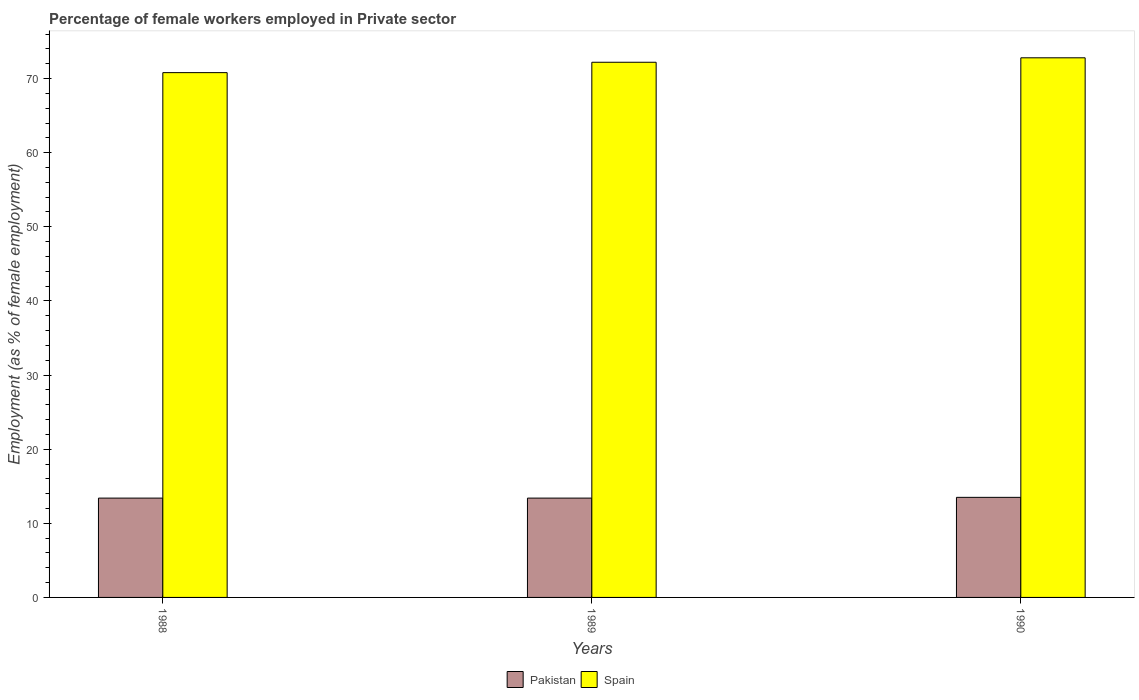How many different coloured bars are there?
Keep it short and to the point. 2. How many groups of bars are there?
Offer a very short reply. 3. How many bars are there on the 2nd tick from the left?
Ensure brevity in your answer.  2. How many bars are there on the 2nd tick from the right?
Ensure brevity in your answer.  2. In how many cases, is the number of bars for a given year not equal to the number of legend labels?
Your response must be concise. 0. What is the percentage of females employed in Private sector in Pakistan in 1989?
Ensure brevity in your answer.  13.4. Across all years, what is the maximum percentage of females employed in Private sector in Spain?
Offer a very short reply. 72.8. Across all years, what is the minimum percentage of females employed in Private sector in Spain?
Make the answer very short. 70.8. In which year was the percentage of females employed in Private sector in Pakistan maximum?
Provide a succinct answer. 1990. What is the total percentage of females employed in Private sector in Pakistan in the graph?
Your response must be concise. 40.3. What is the difference between the percentage of females employed in Private sector in Pakistan in 1989 and that in 1990?
Offer a very short reply. -0.1. What is the difference between the percentage of females employed in Private sector in Spain in 1989 and the percentage of females employed in Private sector in Pakistan in 1990?
Give a very brief answer. 58.7. What is the average percentage of females employed in Private sector in Pakistan per year?
Offer a very short reply. 13.43. In the year 1988, what is the difference between the percentage of females employed in Private sector in Spain and percentage of females employed in Private sector in Pakistan?
Provide a succinct answer. 57.4. In how many years, is the percentage of females employed in Private sector in Pakistan greater than 60 %?
Provide a succinct answer. 0. Is the difference between the percentage of females employed in Private sector in Spain in 1989 and 1990 greater than the difference between the percentage of females employed in Private sector in Pakistan in 1989 and 1990?
Provide a succinct answer. No. What is the difference between the highest and the second highest percentage of females employed in Private sector in Spain?
Your response must be concise. 0.6. What is the difference between the highest and the lowest percentage of females employed in Private sector in Pakistan?
Your answer should be very brief. 0.1. What does the 1st bar from the right in 1988 represents?
Offer a very short reply. Spain. How many bars are there?
Your answer should be compact. 6. Are all the bars in the graph horizontal?
Your response must be concise. No. How many years are there in the graph?
Your answer should be very brief. 3. Does the graph contain grids?
Make the answer very short. No. How are the legend labels stacked?
Your response must be concise. Horizontal. What is the title of the graph?
Provide a succinct answer. Percentage of female workers employed in Private sector. Does "Antigua and Barbuda" appear as one of the legend labels in the graph?
Offer a very short reply. No. What is the label or title of the Y-axis?
Provide a succinct answer. Employment (as % of female employment). What is the Employment (as % of female employment) of Pakistan in 1988?
Your response must be concise. 13.4. What is the Employment (as % of female employment) in Spain in 1988?
Your response must be concise. 70.8. What is the Employment (as % of female employment) of Pakistan in 1989?
Offer a very short reply. 13.4. What is the Employment (as % of female employment) in Spain in 1989?
Provide a short and direct response. 72.2. What is the Employment (as % of female employment) of Pakistan in 1990?
Ensure brevity in your answer.  13.5. What is the Employment (as % of female employment) in Spain in 1990?
Provide a succinct answer. 72.8. Across all years, what is the maximum Employment (as % of female employment) of Spain?
Make the answer very short. 72.8. Across all years, what is the minimum Employment (as % of female employment) of Pakistan?
Provide a short and direct response. 13.4. Across all years, what is the minimum Employment (as % of female employment) of Spain?
Offer a terse response. 70.8. What is the total Employment (as % of female employment) of Pakistan in the graph?
Offer a very short reply. 40.3. What is the total Employment (as % of female employment) of Spain in the graph?
Give a very brief answer. 215.8. What is the difference between the Employment (as % of female employment) in Pakistan in 1988 and the Employment (as % of female employment) in Spain in 1989?
Your response must be concise. -58.8. What is the difference between the Employment (as % of female employment) of Pakistan in 1988 and the Employment (as % of female employment) of Spain in 1990?
Keep it short and to the point. -59.4. What is the difference between the Employment (as % of female employment) in Pakistan in 1989 and the Employment (as % of female employment) in Spain in 1990?
Provide a succinct answer. -59.4. What is the average Employment (as % of female employment) in Pakistan per year?
Keep it short and to the point. 13.43. What is the average Employment (as % of female employment) in Spain per year?
Your answer should be compact. 71.93. In the year 1988, what is the difference between the Employment (as % of female employment) of Pakistan and Employment (as % of female employment) of Spain?
Give a very brief answer. -57.4. In the year 1989, what is the difference between the Employment (as % of female employment) in Pakistan and Employment (as % of female employment) in Spain?
Provide a short and direct response. -58.8. In the year 1990, what is the difference between the Employment (as % of female employment) in Pakistan and Employment (as % of female employment) in Spain?
Your response must be concise. -59.3. What is the ratio of the Employment (as % of female employment) in Pakistan in 1988 to that in 1989?
Provide a short and direct response. 1. What is the ratio of the Employment (as % of female employment) in Spain in 1988 to that in 1989?
Give a very brief answer. 0.98. What is the ratio of the Employment (as % of female employment) in Pakistan in 1988 to that in 1990?
Offer a terse response. 0.99. What is the ratio of the Employment (as % of female employment) in Spain in 1988 to that in 1990?
Give a very brief answer. 0.97. What is the ratio of the Employment (as % of female employment) of Spain in 1989 to that in 1990?
Provide a succinct answer. 0.99. What is the difference between the highest and the second highest Employment (as % of female employment) of Spain?
Your response must be concise. 0.6. What is the difference between the highest and the lowest Employment (as % of female employment) of Pakistan?
Provide a succinct answer. 0.1. What is the difference between the highest and the lowest Employment (as % of female employment) in Spain?
Provide a succinct answer. 2. 